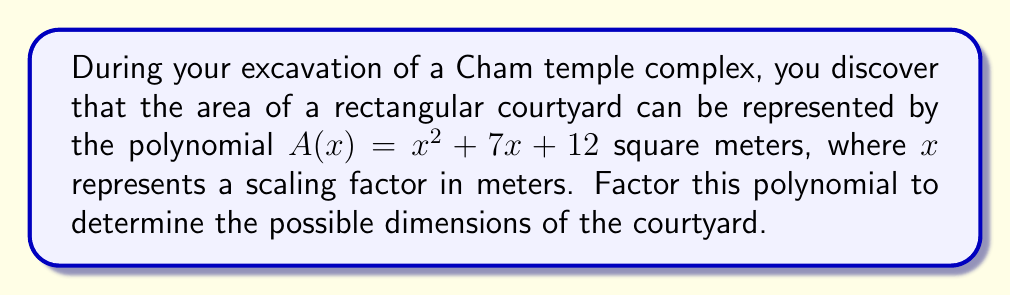Can you answer this question? To factor the polynomial $A(x) = x^2 + 7x + 12$, we'll use the following steps:

1) First, we need to find two numbers that multiply to give the constant term (12) and add up to the coefficient of x (7).

2) The factors of 12 are: 1, 2, 3, 4, 6, and 12.

3) By inspection, we can see that 3 and 4 multiply to give 12 and add up to 7.

4) Therefore, we can rewrite the middle term as:

   $x^2 + 7x + 12 = x^2 + 3x + 4x + 12$

5) Now we can group the terms:

   $(x^2 + 3x) + (4x + 12)$

6) Factor out the common factors from each group:

   $x(x + 3) + 4(x + 3)$

7) We can now factor out the common binomial $(x + 3)$:

   $(x + 3)(x + 4)$

Thus, the polynomial $x^2 + 7x + 12$ factors to $(x + 3)(x + 4)$.

In the context of the Cham temple courtyard, this means that the length of the courtyard is $(x + 3)$ meters and the width is $(x + 4)$ meters, where $x$ is the scaling factor.
Answer: $(x + 3)(x + 4)$ 